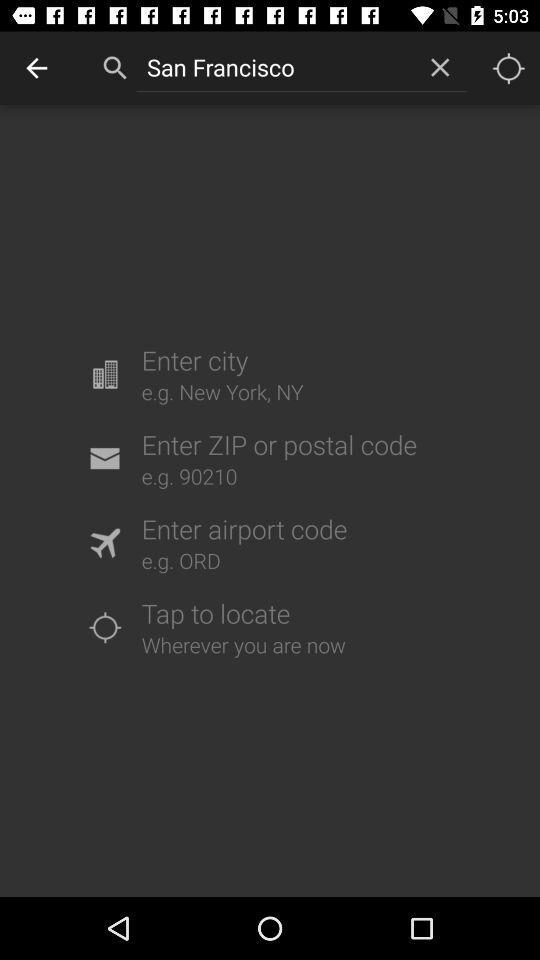How many options are there to search for a location?
Answer the question using a single word or phrase. 4 